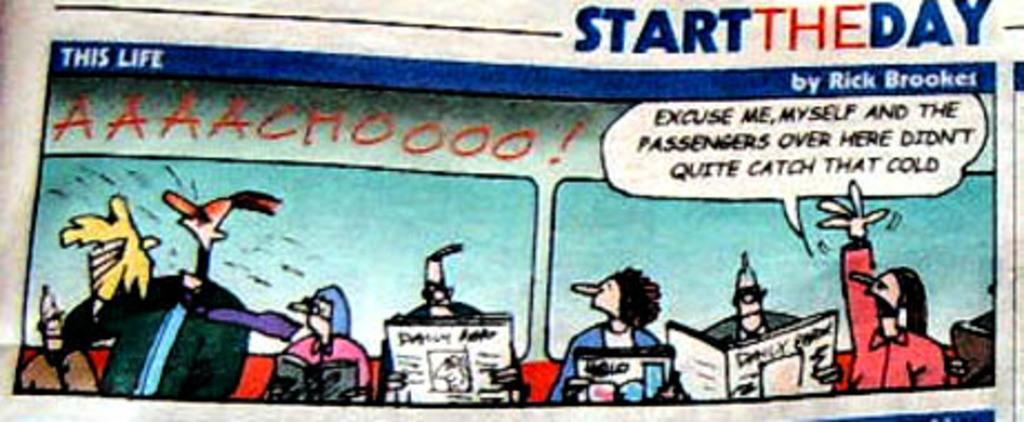Please provide a concise description of this image. In this image, this looks like a paper. I can see the cartoon images and the letters on the paper. 